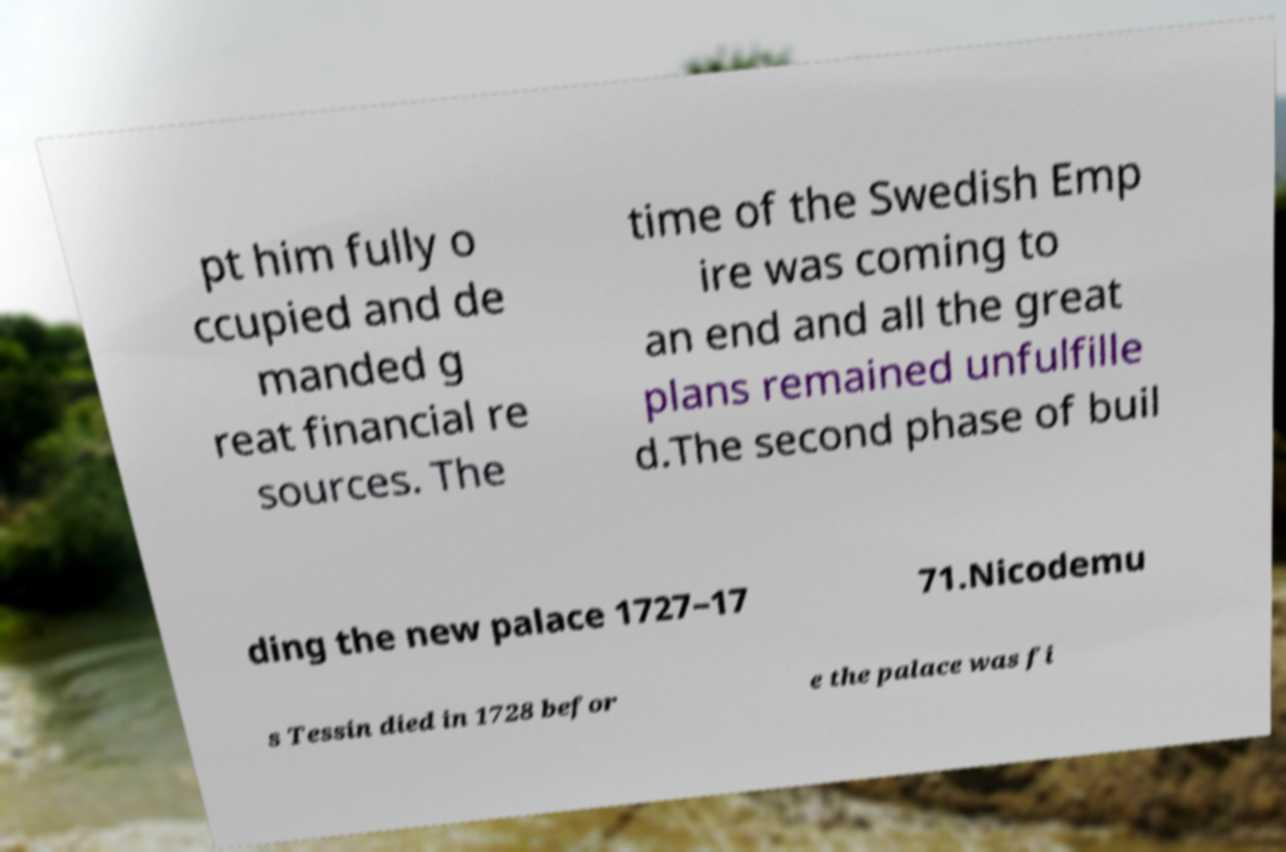Could you assist in decoding the text presented in this image and type it out clearly? pt him fully o ccupied and de manded g reat financial re sources. The time of the Swedish Emp ire was coming to an end and all the great plans remained unfulfille d.The second phase of buil ding the new palace 1727–17 71.Nicodemu s Tessin died in 1728 befor e the palace was fi 